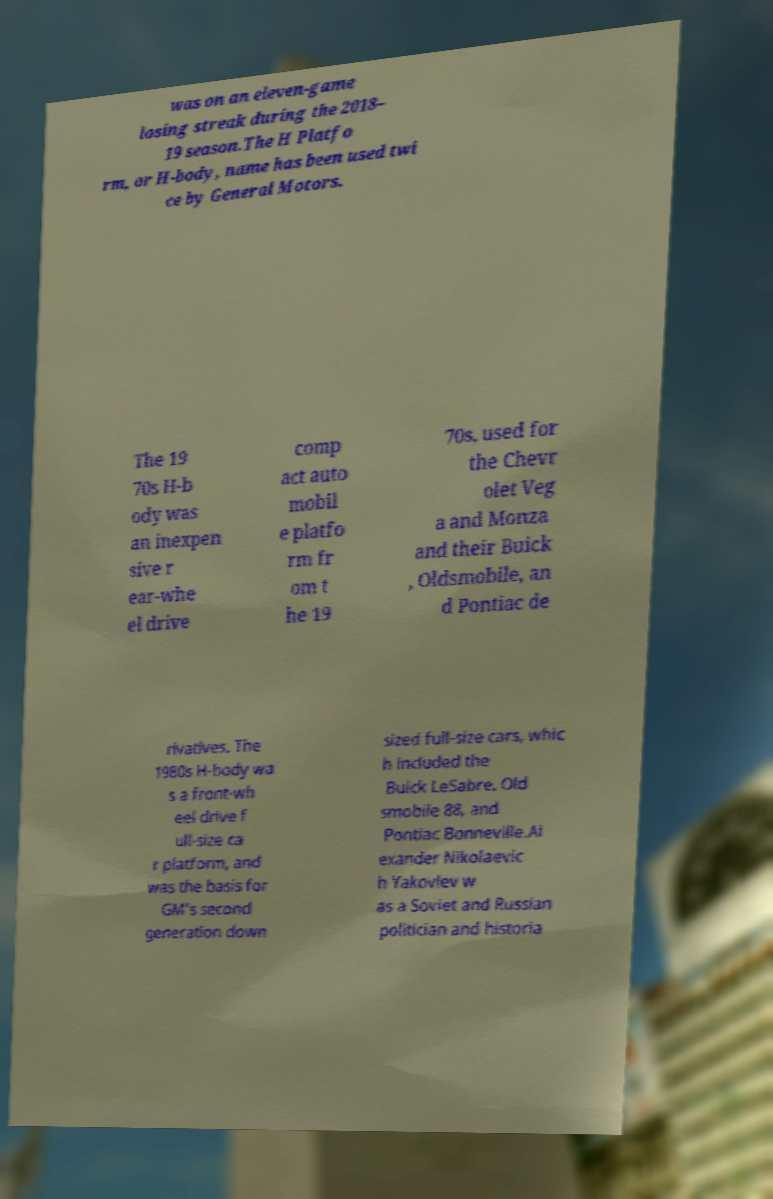Please read and relay the text visible in this image. What does it say? was on an eleven-game losing streak during the 2018– 19 season.The H Platfo rm, or H-body, name has been used twi ce by General Motors. The 19 70s H-b ody was an inexpen sive r ear-whe el drive comp act auto mobil e platfo rm fr om t he 19 70s, used for the Chevr olet Veg a and Monza and their Buick , Oldsmobile, an d Pontiac de rivatives. The 1980s H-body wa s a front-wh eel drive f ull-size ca r platform, and was the basis for GM's second generation down sized full-size cars, whic h included the Buick LeSabre, Old smobile 88, and Pontiac Bonneville.Al exander Nikolaevic h Yakovlev w as a Soviet and Russian politician and historia 